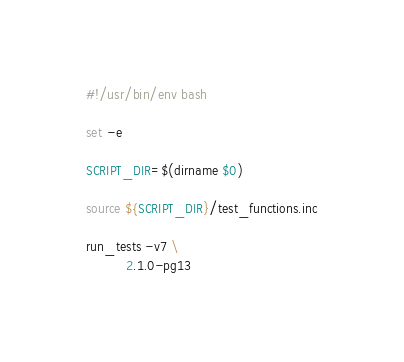<code> <loc_0><loc_0><loc_500><loc_500><_Bash_>#!/usr/bin/env bash

set -e

SCRIPT_DIR=$(dirname $0)

source ${SCRIPT_DIR}/test_functions.inc

run_tests -v7 \
          2.1.0-pg13
</code> 